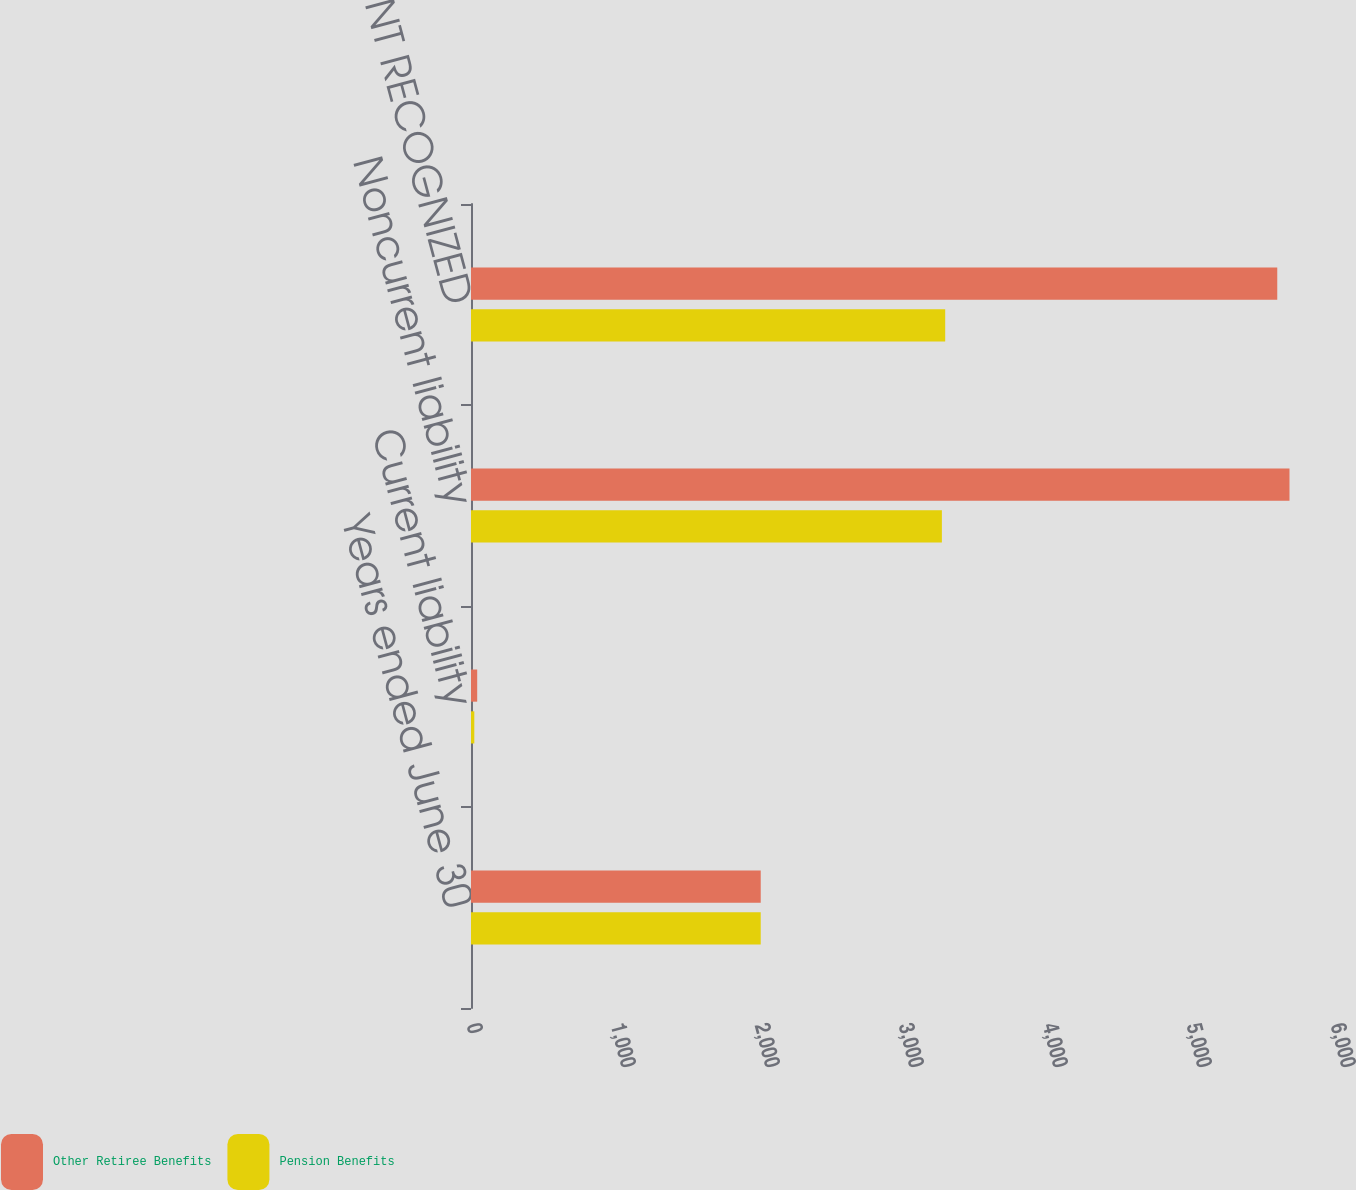Convert chart to OTSL. <chart><loc_0><loc_0><loc_500><loc_500><stacked_bar_chart><ecel><fcel>Years ended June 30<fcel>Current liability<fcel>Noncurrent liability<fcel>NET AMOUNT RECOGNIZED<nl><fcel>Other Retiree Benefits<fcel>2012<fcel>43<fcel>5684<fcel>5599<nl><fcel>Pension Benefits<fcel>2012<fcel>23<fcel>3270<fcel>3293<nl></chart> 